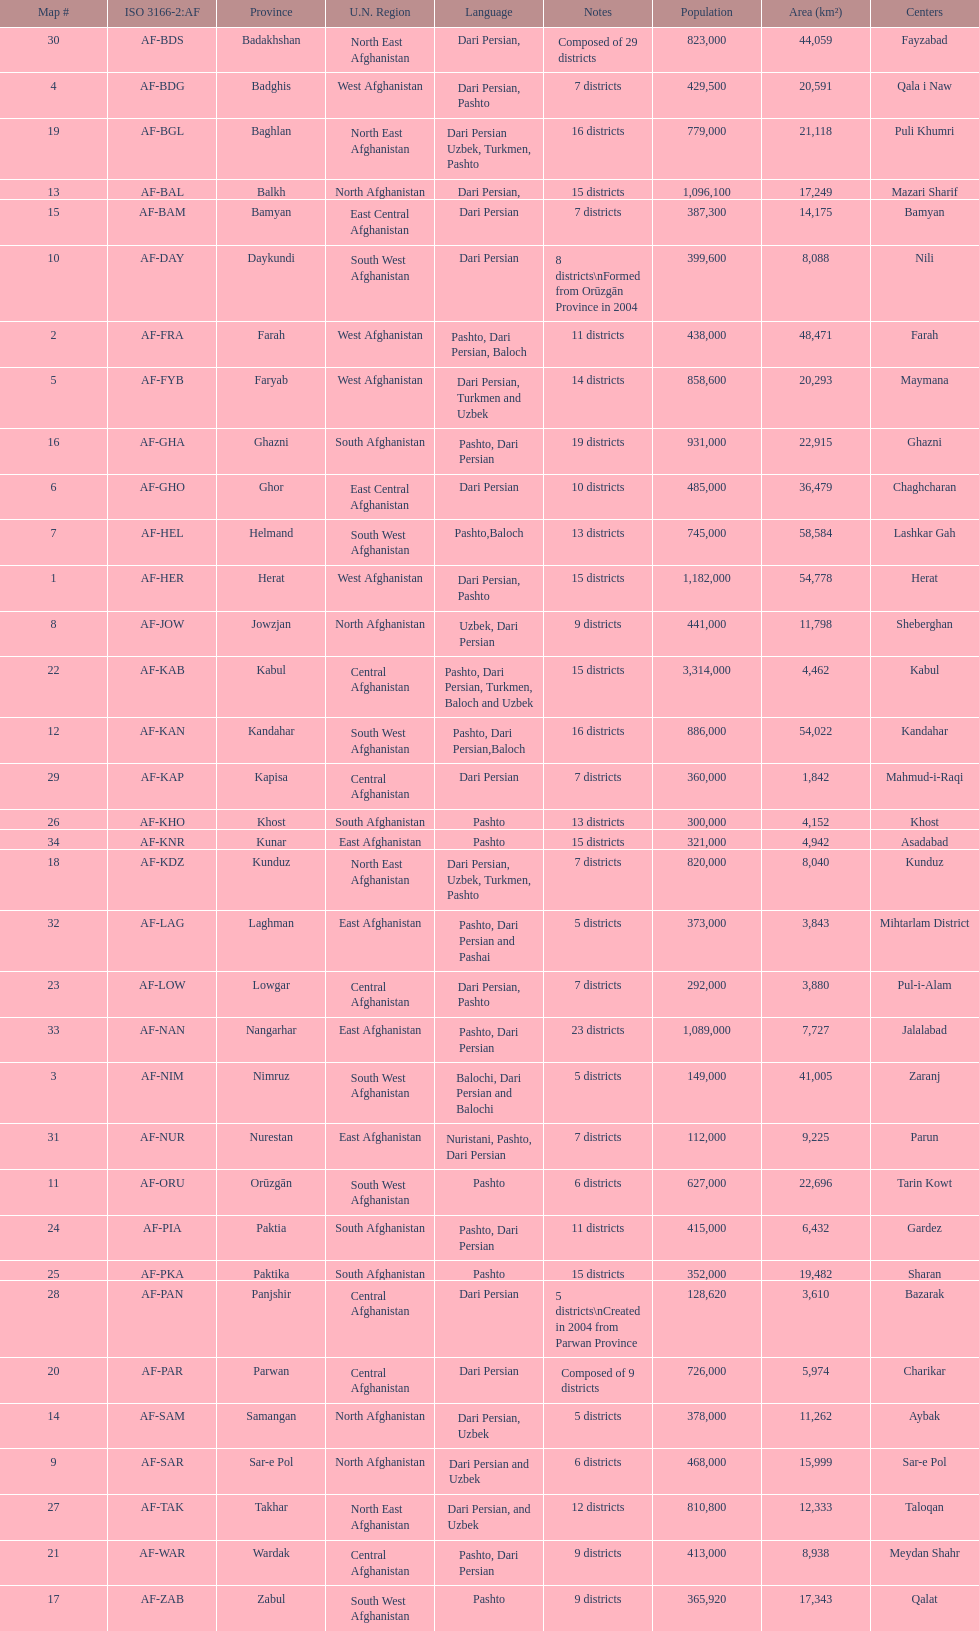Give the province with the least population Nurestan. 